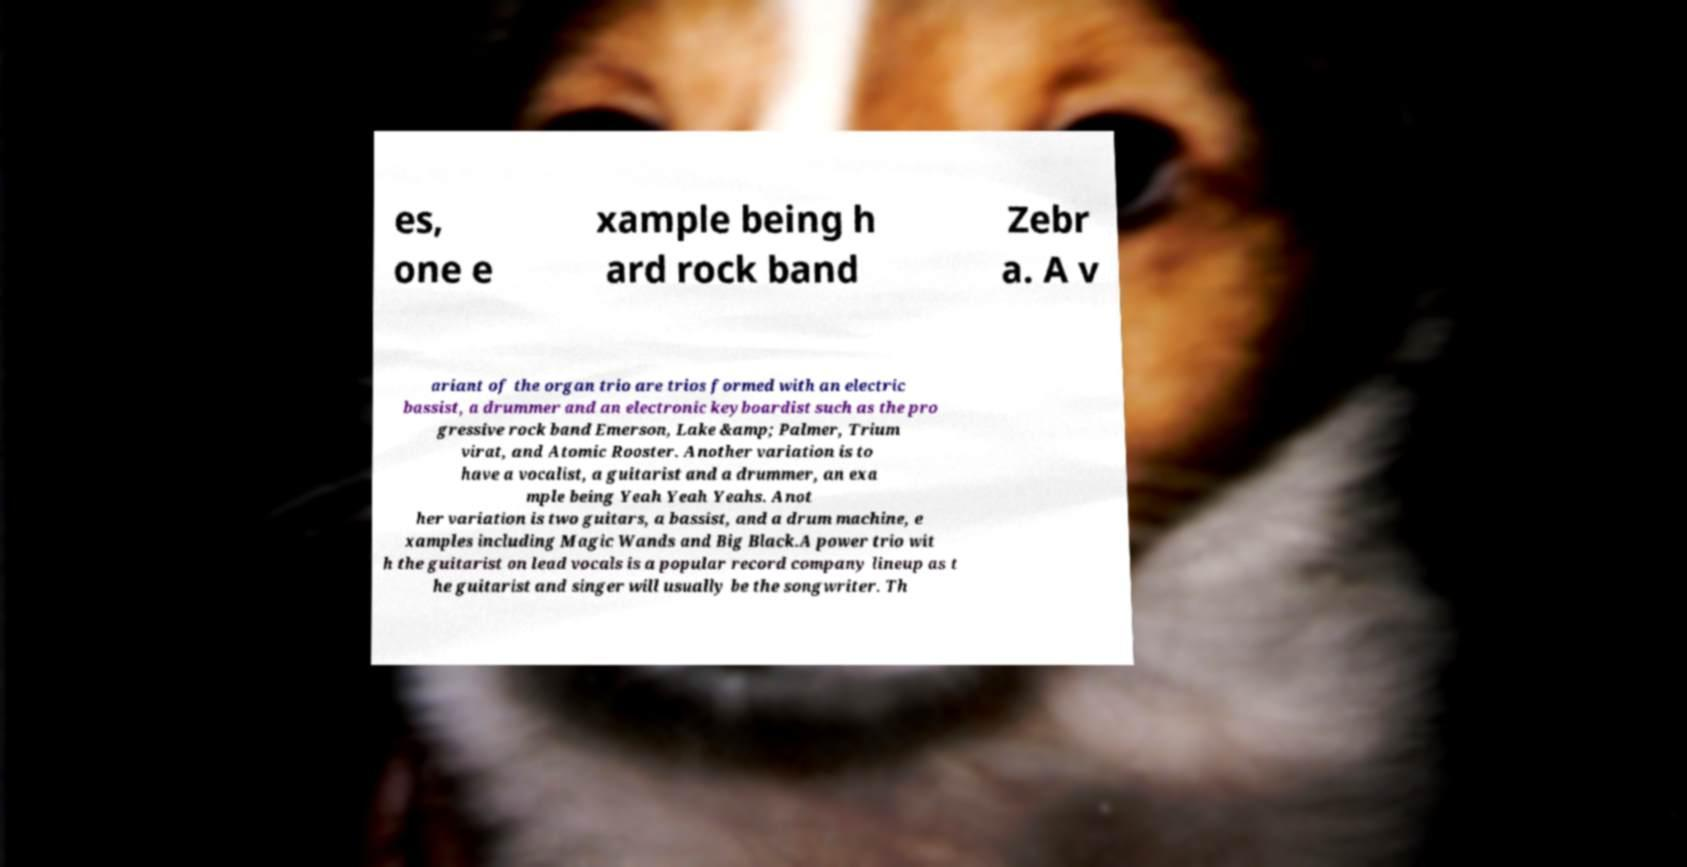There's text embedded in this image that I need extracted. Can you transcribe it verbatim? es, one e xample being h ard rock band Zebr a. A v ariant of the organ trio are trios formed with an electric bassist, a drummer and an electronic keyboardist such as the pro gressive rock band Emerson, Lake &amp; Palmer, Trium virat, and Atomic Rooster. Another variation is to have a vocalist, a guitarist and a drummer, an exa mple being Yeah Yeah Yeahs. Anot her variation is two guitars, a bassist, and a drum machine, e xamples including Magic Wands and Big Black.A power trio wit h the guitarist on lead vocals is a popular record company lineup as t he guitarist and singer will usually be the songwriter. Th 